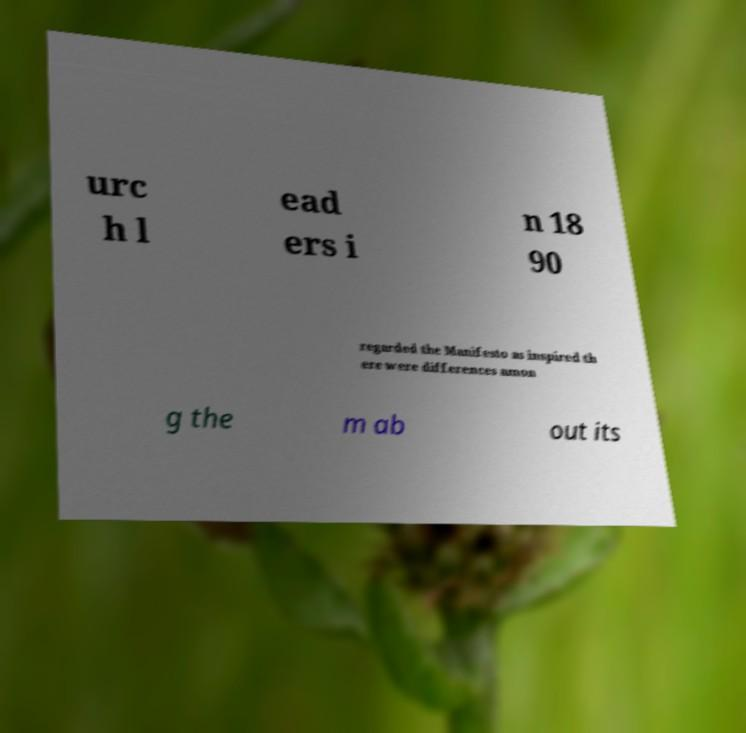There's text embedded in this image that I need extracted. Can you transcribe it verbatim? urc h l ead ers i n 18 90 regarded the Manifesto as inspired th ere were differences amon g the m ab out its 